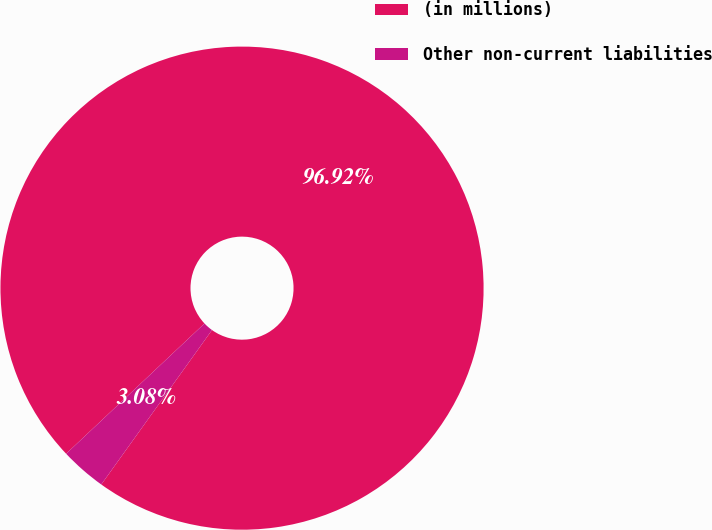Convert chart. <chart><loc_0><loc_0><loc_500><loc_500><pie_chart><fcel>(in millions)<fcel>Other non-current liabilities<nl><fcel>96.92%<fcel>3.08%<nl></chart> 